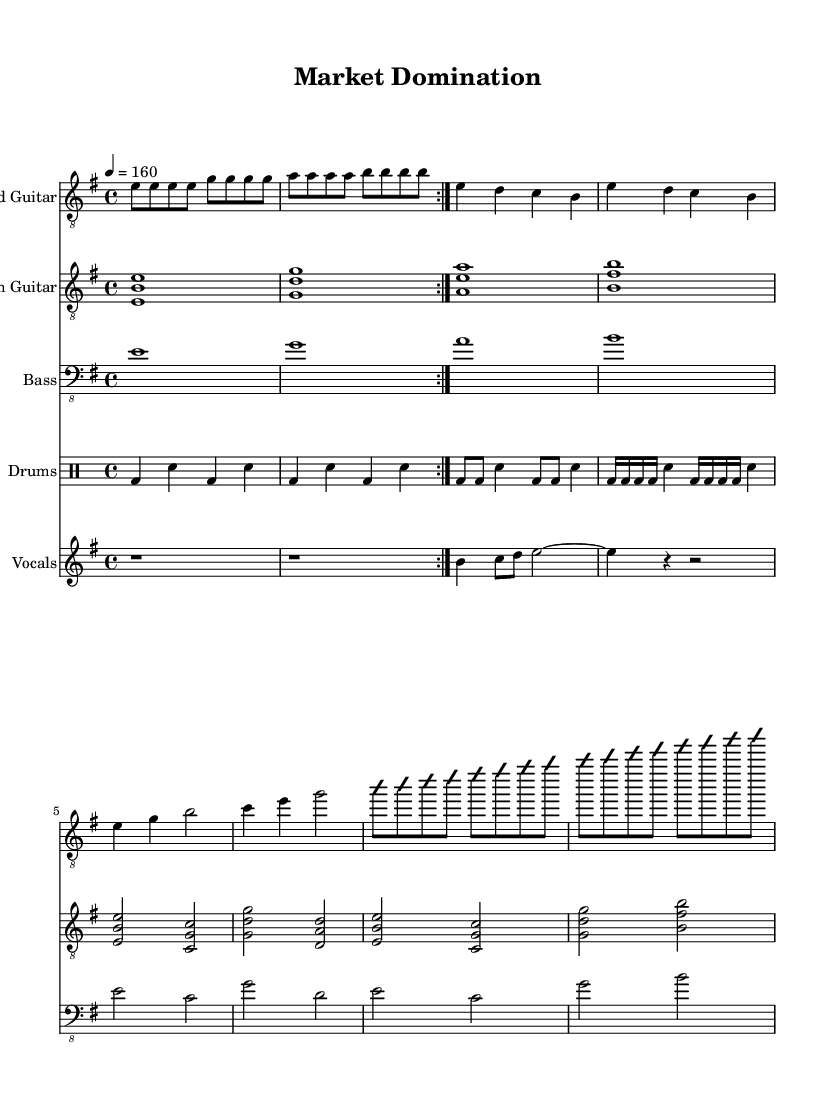What is the key signature of this music? The key signature is E minor, which has one sharp (F#) indicated in the global section of the LilyPond code.
Answer: E minor What is the time signature for this piece? The time signature is 4/4, which is specified in the global section of the code, indicating there are four beats per measure.
Answer: 4/4 What is the tempo marking for this music? The tempo is marked at 160 beats per minute, as stated in the global section, which indicates the speed at which the piece should be played.
Answer: 160 How many measures are in the intro? The intro consists of 8 measures, as seen in the guitar parts where the intro is repeated twice with each part containing four measures.
Answer: 8 Which instruments are featured in this score? The instruments featured are Lead Guitar, Rhythm Guitar, Bass, Drums, and Vocals, as noted in the score staff section.
Answer: Lead Guitar, Rhythm Guitar, Bass, Drums, Vocals What type of musical section is indicated by "Solo" in the guitar parts? The "Solo" section is an improvisation, which means that the player can create their own melodic lines within the given framework, as indicated by the "improvisationOn" and "improvisationOff" markers.
Answer: Improvisation What do the vocal parts consist of during the verse? During the verse, the vocal parts consist of rests, explicitly indicated by "r1" for one measure of rest, showing no vocal activity in that section.
Answer: Rests 